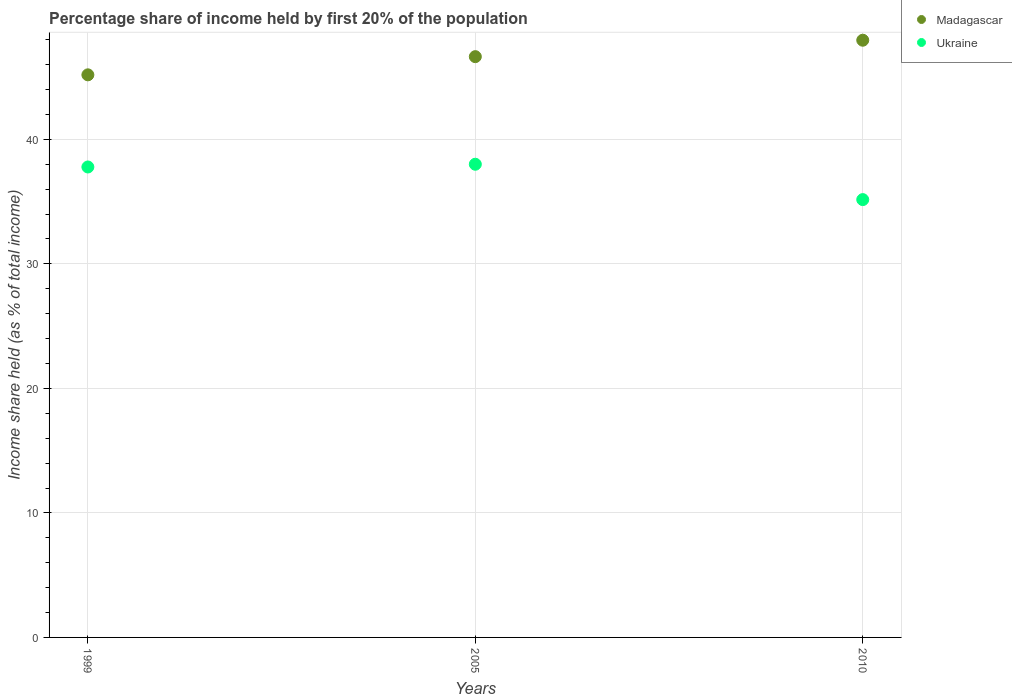Is the number of dotlines equal to the number of legend labels?
Your response must be concise. Yes. What is the share of income held by first 20% of the population in Ukraine in 1999?
Make the answer very short. 37.78. Across all years, what is the minimum share of income held by first 20% of the population in Madagascar?
Offer a terse response. 45.18. In which year was the share of income held by first 20% of the population in Madagascar maximum?
Offer a terse response. 2010. What is the total share of income held by first 20% of the population in Ukraine in the graph?
Provide a succinct answer. 110.94. What is the difference between the share of income held by first 20% of the population in Madagascar in 1999 and that in 2010?
Provide a succinct answer. -2.78. What is the difference between the share of income held by first 20% of the population in Ukraine in 1999 and the share of income held by first 20% of the population in Madagascar in 2010?
Your response must be concise. -10.18. What is the average share of income held by first 20% of the population in Ukraine per year?
Offer a terse response. 36.98. In the year 1999, what is the difference between the share of income held by first 20% of the population in Ukraine and share of income held by first 20% of the population in Madagascar?
Keep it short and to the point. -7.4. What is the ratio of the share of income held by first 20% of the population in Ukraine in 1999 to that in 2005?
Give a very brief answer. 0.99. Is the difference between the share of income held by first 20% of the population in Ukraine in 1999 and 2005 greater than the difference between the share of income held by first 20% of the population in Madagascar in 1999 and 2005?
Your answer should be compact. Yes. What is the difference between the highest and the second highest share of income held by first 20% of the population in Madagascar?
Ensure brevity in your answer.  1.32. What is the difference between the highest and the lowest share of income held by first 20% of the population in Madagascar?
Make the answer very short. 2.78. In how many years, is the share of income held by first 20% of the population in Ukraine greater than the average share of income held by first 20% of the population in Ukraine taken over all years?
Offer a very short reply. 2. Is the share of income held by first 20% of the population in Madagascar strictly less than the share of income held by first 20% of the population in Ukraine over the years?
Offer a very short reply. No. How many dotlines are there?
Ensure brevity in your answer.  2. How many years are there in the graph?
Make the answer very short. 3. What is the difference between two consecutive major ticks on the Y-axis?
Make the answer very short. 10. How many legend labels are there?
Make the answer very short. 2. How are the legend labels stacked?
Ensure brevity in your answer.  Vertical. What is the title of the graph?
Provide a short and direct response. Percentage share of income held by first 20% of the population. Does "St. Vincent and the Grenadines" appear as one of the legend labels in the graph?
Make the answer very short. No. What is the label or title of the X-axis?
Make the answer very short. Years. What is the label or title of the Y-axis?
Provide a short and direct response. Income share held (as % of total income). What is the Income share held (as % of total income) of Madagascar in 1999?
Your answer should be very brief. 45.18. What is the Income share held (as % of total income) of Ukraine in 1999?
Your answer should be very brief. 37.78. What is the Income share held (as % of total income) of Madagascar in 2005?
Provide a succinct answer. 46.64. What is the Income share held (as % of total income) in Ukraine in 2005?
Provide a succinct answer. 38. What is the Income share held (as % of total income) in Madagascar in 2010?
Make the answer very short. 47.96. What is the Income share held (as % of total income) in Ukraine in 2010?
Ensure brevity in your answer.  35.16. Across all years, what is the maximum Income share held (as % of total income) in Madagascar?
Your response must be concise. 47.96. Across all years, what is the minimum Income share held (as % of total income) in Madagascar?
Offer a terse response. 45.18. Across all years, what is the minimum Income share held (as % of total income) in Ukraine?
Give a very brief answer. 35.16. What is the total Income share held (as % of total income) of Madagascar in the graph?
Make the answer very short. 139.78. What is the total Income share held (as % of total income) in Ukraine in the graph?
Ensure brevity in your answer.  110.94. What is the difference between the Income share held (as % of total income) in Madagascar in 1999 and that in 2005?
Your answer should be compact. -1.46. What is the difference between the Income share held (as % of total income) in Ukraine in 1999 and that in 2005?
Your answer should be compact. -0.22. What is the difference between the Income share held (as % of total income) in Madagascar in 1999 and that in 2010?
Ensure brevity in your answer.  -2.78. What is the difference between the Income share held (as % of total income) of Ukraine in 1999 and that in 2010?
Ensure brevity in your answer.  2.62. What is the difference between the Income share held (as % of total income) in Madagascar in 2005 and that in 2010?
Make the answer very short. -1.32. What is the difference between the Income share held (as % of total income) in Ukraine in 2005 and that in 2010?
Offer a terse response. 2.84. What is the difference between the Income share held (as % of total income) in Madagascar in 1999 and the Income share held (as % of total income) in Ukraine in 2005?
Your response must be concise. 7.18. What is the difference between the Income share held (as % of total income) of Madagascar in 1999 and the Income share held (as % of total income) of Ukraine in 2010?
Your answer should be very brief. 10.02. What is the difference between the Income share held (as % of total income) in Madagascar in 2005 and the Income share held (as % of total income) in Ukraine in 2010?
Provide a short and direct response. 11.48. What is the average Income share held (as % of total income) in Madagascar per year?
Ensure brevity in your answer.  46.59. What is the average Income share held (as % of total income) in Ukraine per year?
Provide a short and direct response. 36.98. In the year 2005, what is the difference between the Income share held (as % of total income) in Madagascar and Income share held (as % of total income) in Ukraine?
Keep it short and to the point. 8.64. What is the ratio of the Income share held (as % of total income) of Madagascar in 1999 to that in 2005?
Provide a short and direct response. 0.97. What is the ratio of the Income share held (as % of total income) of Madagascar in 1999 to that in 2010?
Provide a succinct answer. 0.94. What is the ratio of the Income share held (as % of total income) of Ukraine in 1999 to that in 2010?
Give a very brief answer. 1.07. What is the ratio of the Income share held (as % of total income) of Madagascar in 2005 to that in 2010?
Offer a very short reply. 0.97. What is the ratio of the Income share held (as % of total income) of Ukraine in 2005 to that in 2010?
Offer a terse response. 1.08. What is the difference between the highest and the second highest Income share held (as % of total income) of Madagascar?
Your response must be concise. 1.32. What is the difference between the highest and the second highest Income share held (as % of total income) of Ukraine?
Offer a very short reply. 0.22. What is the difference between the highest and the lowest Income share held (as % of total income) in Madagascar?
Provide a short and direct response. 2.78. What is the difference between the highest and the lowest Income share held (as % of total income) of Ukraine?
Provide a succinct answer. 2.84. 